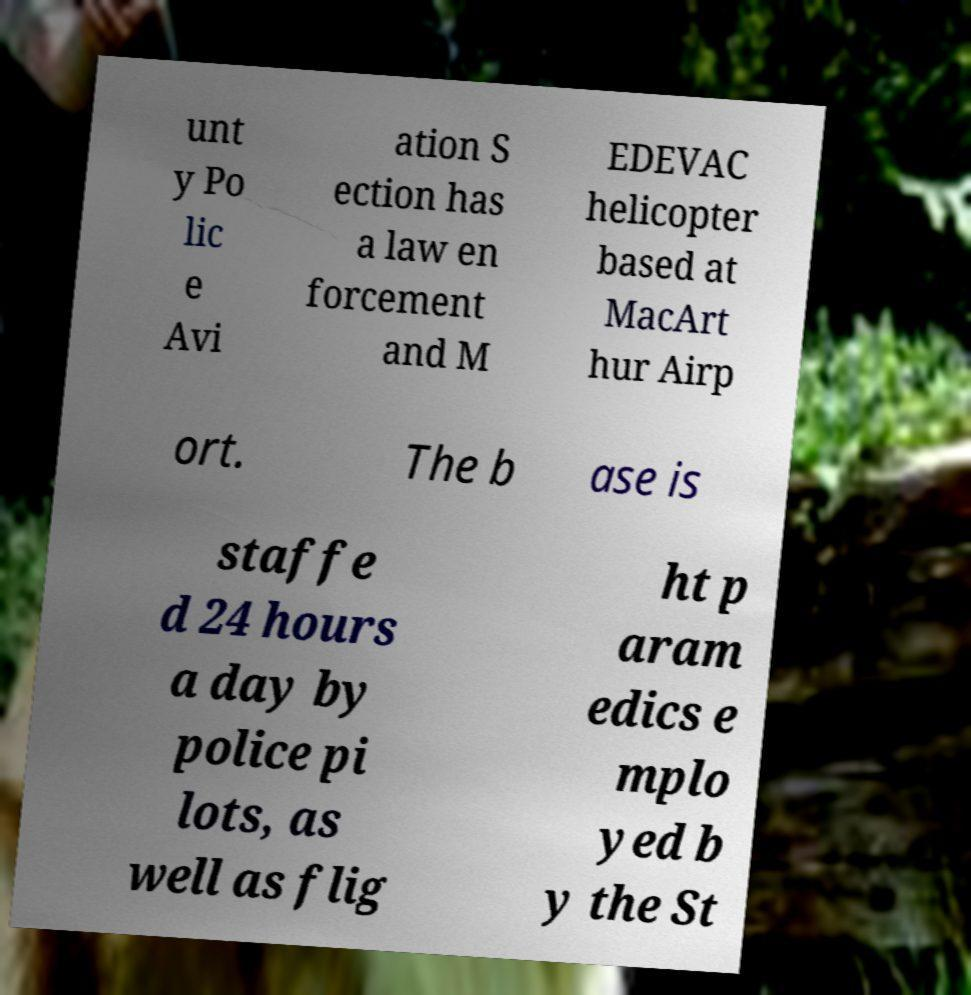I need the written content from this picture converted into text. Can you do that? unt y Po lic e Avi ation S ection has a law en forcement and M EDEVAC helicopter based at MacArt hur Airp ort. The b ase is staffe d 24 hours a day by police pi lots, as well as flig ht p aram edics e mplo yed b y the St 